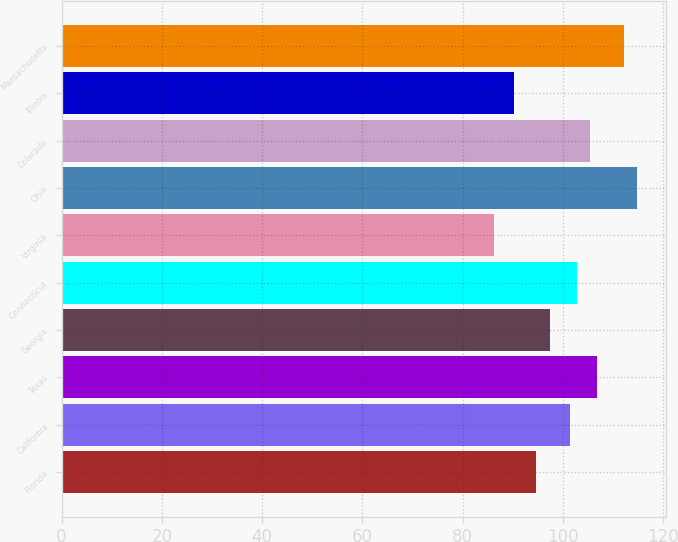Convert chart to OTSL. <chart><loc_0><loc_0><loc_500><loc_500><bar_chart><fcel>Florida<fcel>California<fcel>Texas<fcel>Georgia<fcel>Connecticut<fcel>Virginia<fcel>Ohio<fcel>Colorado<fcel>Illinois<fcel>Massachusetts<nl><fcel>94.7<fcel>101.4<fcel>106.76<fcel>97.38<fcel>102.74<fcel>86.3<fcel>114.8<fcel>105.42<fcel>90.32<fcel>112.12<nl></chart> 